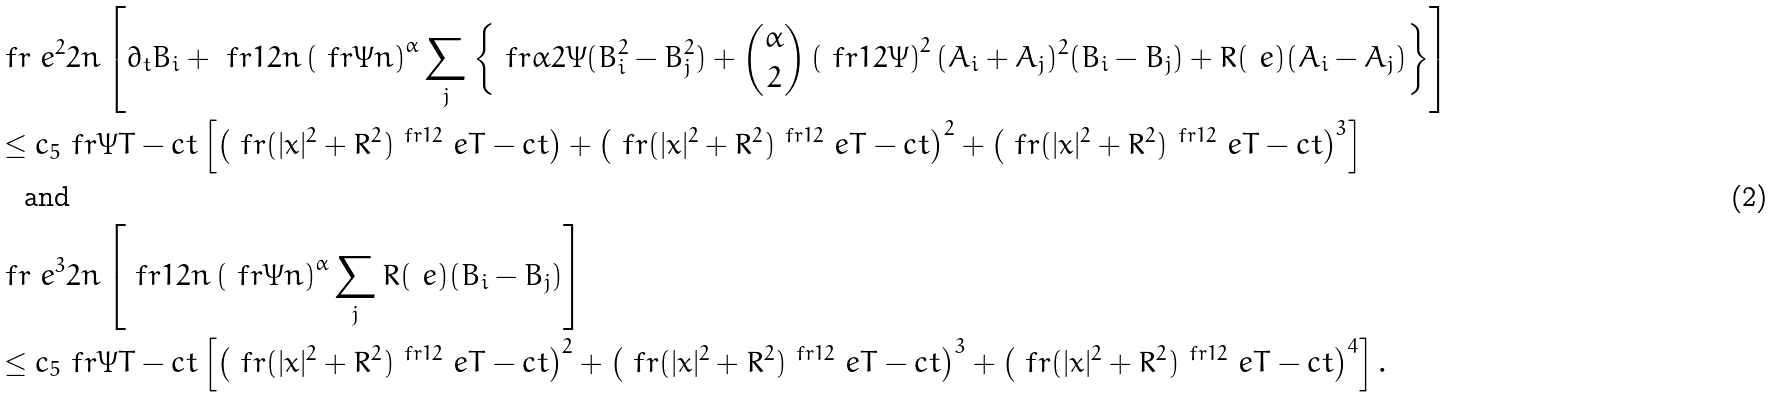<formula> <loc_0><loc_0><loc_500><loc_500>& \ f r { \ e ^ { 2 } } { 2 n } \left [ \partial _ { t } B _ { i } + \ f r { 1 } { 2 n } \left ( \ f r { \Psi } { n } \right ) ^ { \alpha } \sum _ { j } \left \{ \ f r { \alpha } { 2 \Psi } ( B _ { i } ^ { 2 } - B _ { j } ^ { 2 } ) + \binom { \alpha } { 2 } \left ( \ f r { 1 } { 2 \Psi } \right ) ^ { 2 } ( A _ { i } + A _ { j } ) ^ { 2 } ( B _ { i } - B _ { j } ) + R ( \ e ) ( A _ { i } - A _ { j } ) \right \} \right ] \\ & \leq c _ { 5 } \ f r { \Psi } { T - c t } \left [ \left ( \ f r { ( | x | ^ { 2 } + R ^ { 2 } ) ^ { \ f r { 1 } { 2 } } \ e } { T - c t } \right ) + \left ( \ f r { ( | x | ^ { 2 } + R ^ { 2 } ) ^ { \ f r { 1 } { 2 } } \ e } { T - c t } \right ) ^ { 2 } + \left ( \ f r { ( | x | ^ { 2 } + R ^ { 2 } ) ^ { \ f r { 1 } { 2 } } \ e } { T - c t } \right ) ^ { 3 } \right ] \\ & \text {\quad and} \\ & \ f r { \ e ^ { 3 } } { 2 n } \left [ \ f r { 1 } { 2 n } \left ( \ f r { \Psi } { n } \right ) ^ { \alpha } \sum _ { j } R ( \ e ) ( B _ { i } - B _ { j } ) \right ] \\ & \leq c _ { 5 } \ f r { \Psi } { T - c t } \left [ \left ( \ f r { ( | x | ^ { 2 } + R ^ { 2 } ) ^ { \ f r { 1 } { 2 } } \ e } { T - c t } \right ) ^ { 2 } + \left ( \ f r { ( | x | ^ { 2 } + R ^ { 2 } ) ^ { \ f r { 1 } { 2 } } \ e } { T - c t } \right ) ^ { 3 } + \left ( \ f r { ( | x | ^ { 2 } + R ^ { 2 } ) ^ { \ f r { 1 } { 2 } } \ e } { T - c t } \right ) ^ { 4 } \right ] .</formula> 